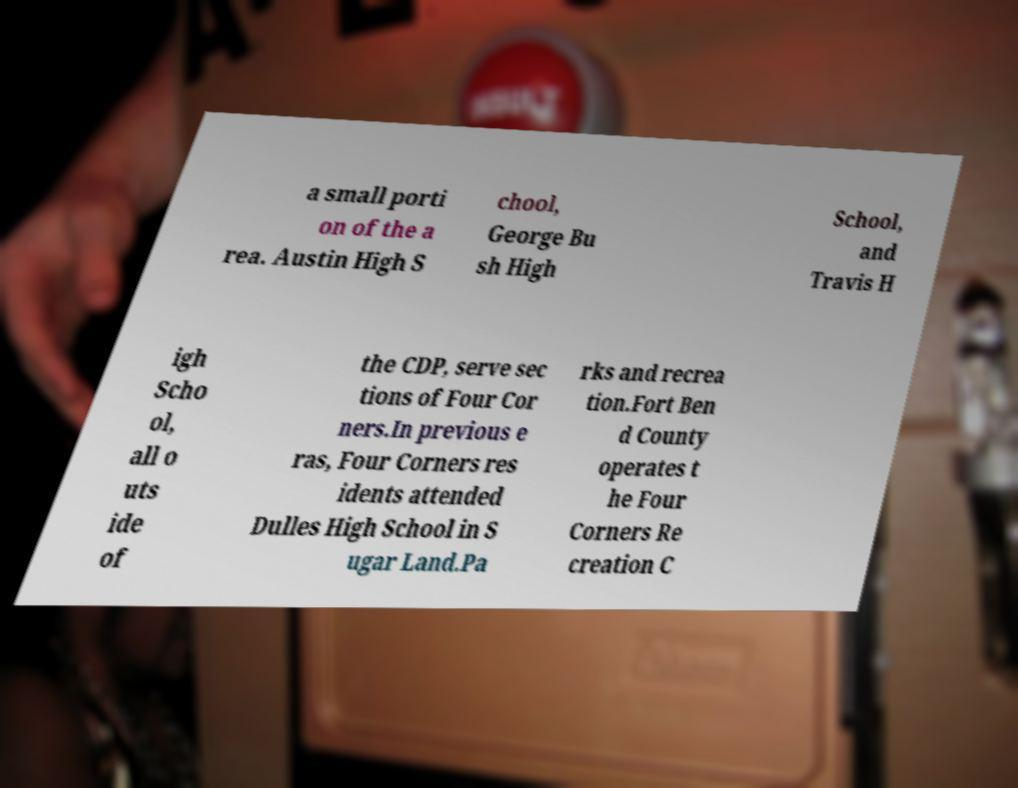What messages or text are displayed in this image? I need them in a readable, typed format. a small porti on of the a rea. Austin High S chool, George Bu sh High School, and Travis H igh Scho ol, all o uts ide of the CDP, serve sec tions of Four Cor ners.In previous e ras, Four Corners res idents attended Dulles High School in S ugar Land.Pa rks and recrea tion.Fort Ben d County operates t he Four Corners Re creation C 